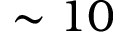<formula> <loc_0><loc_0><loc_500><loc_500>\sim 1 0</formula> 